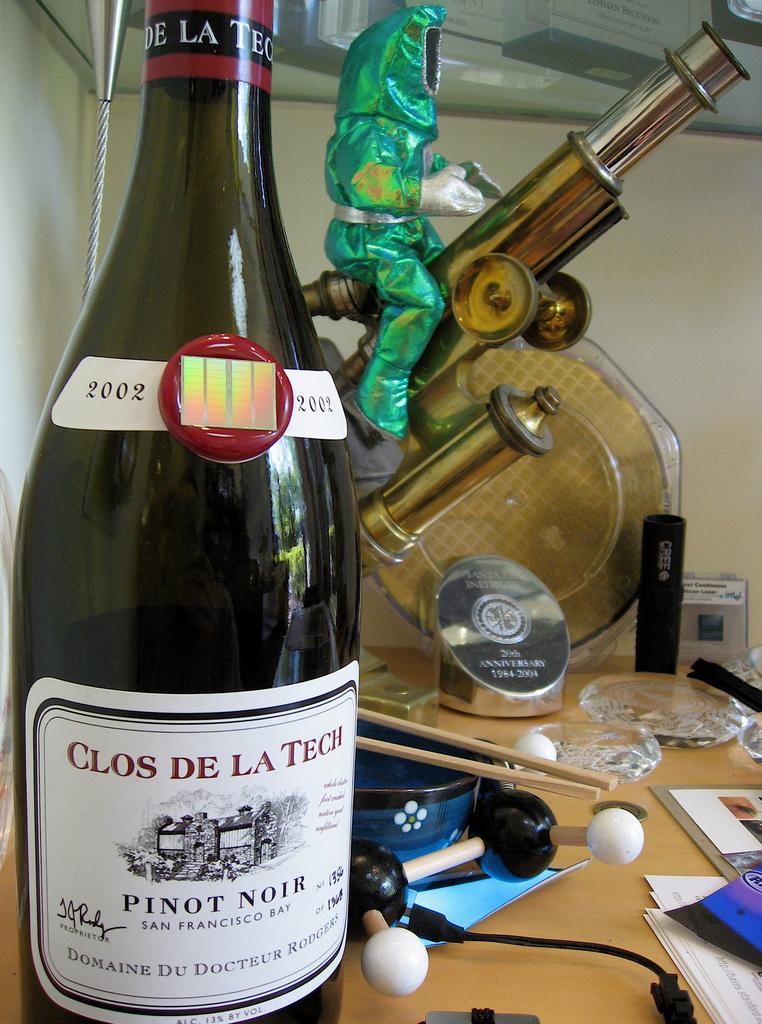What is the vintage of the wine?
Give a very brief answer. 2002. What type of wine is this?
Ensure brevity in your answer.  Pinot noir. 